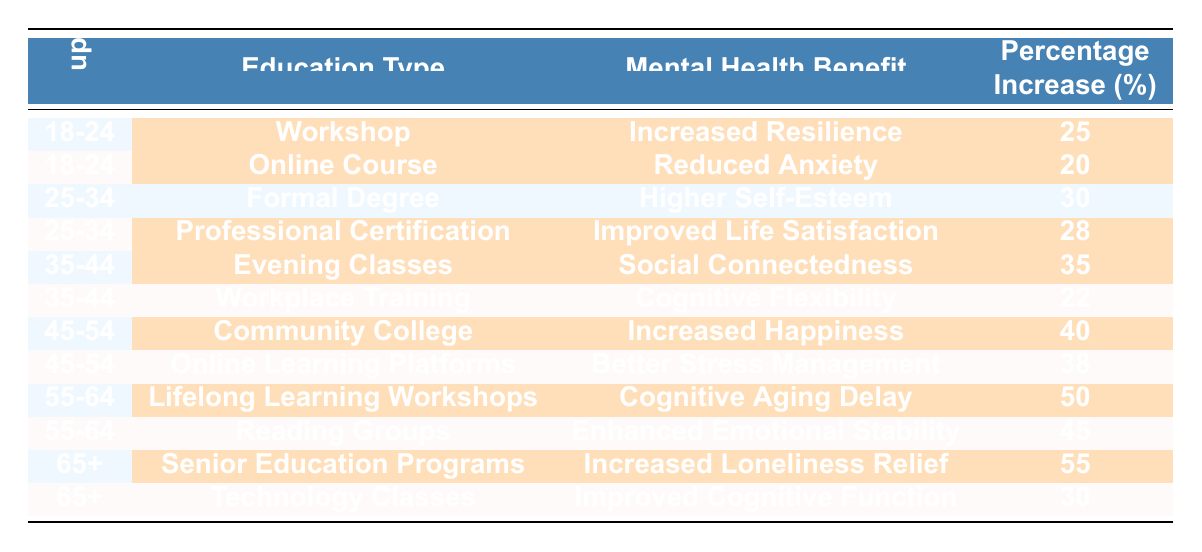What's the mental health benefit associated with the "Online Course" for the age group 18-24? In the table, the "Online Course" for the age group 18-24 has the associated mental health benefit listed as "Reduced Anxiety."
Answer: Reduced Anxiety Which education type has the highest percentage increase in mental health benefit for the age group 65+? For the age group 65+, the "Senior Education Programs" have the highest percentage increase in mental health benefit, which is 55%.
Answer: Senior Education Programs What is the mental health benefit of "Community College" for the age group 45-54, and what is its percentage increase? The table states that the mental health benefit of "Community College" for the age group 45-54 is "Increased Happiness," with a percentage increase of 40%.
Answer: Increased Happiness, 40% Is "Improved Cognitive Function" a mental health benefit provided for adults in the age group 55-64? According to the data in the table, "Improved Cognitive Function" is not listed as a mental health benefit for the 55-64 age group; instead, it is associated with the 65+ age group.
Answer: No What is the average percentage increase of mental health benefits across all education types for the age group 35-44? For age group 35-44, the percentage increases are 35% (Evening Classes) and 22% (Workplace Training). The average is (35 + 22) / 2 = 28.5%.
Answer: 28.5% Which age group shows the least percentage increase in mental health benefits from "Formal Degree"? In the table, the age group 25-34 shows a percentage increase of 30% from "Formal Degree," which is the least among the options presented for any type of continuing education.
Answer: 25-34 Is there a higher percentage increase in mental health benefits for "Lifelong Learning Workshops" than "Reading Groups" for the age group 55-64? The percentage increase for "Lifelong Learning Workshops" is 50%, while for "Reading Groups," it is 45%. Since 50% is greater than 45%, the statement is true.
Answer: Yes What is the total percentage increase from the highlighted benefits for the age group 18-24? For the age group 18-24, the highlighted benefits are "Increased Resilience" (25%) and "Reduced Anxiety" (20%). Therefore, the total percentage increase is 25 + 20 = 45%.
Answer: 45% Which education type benefits the 45-54 age group the most in terms of percentage increase? The highest percentage increase for the 45-54 age group is from "Community College," which shows a 40% increase in mental health benefits.
Answer: Community College How does the mental health benefit of "Evening Classes" compare with "Workplace Training" for the age group 35-44? "Evening Classes" provide a mental health benefit of "Social Connectedness" with a percentage increase of 35%, whereas "Workplace Training" provides "Cognitive Flexibility" with a 22% increase. The benefit from "Evening Classes" is greater.
Answer: Greater benefit from Evening Classes For what age group and education type is "Enhanced Emotional Stability" mentioned? "Enhanced Emotional Stability" is mentioned for the age group 55-64 under "Reading Groups."
Answer: Age group 55-64, Reading Groups 